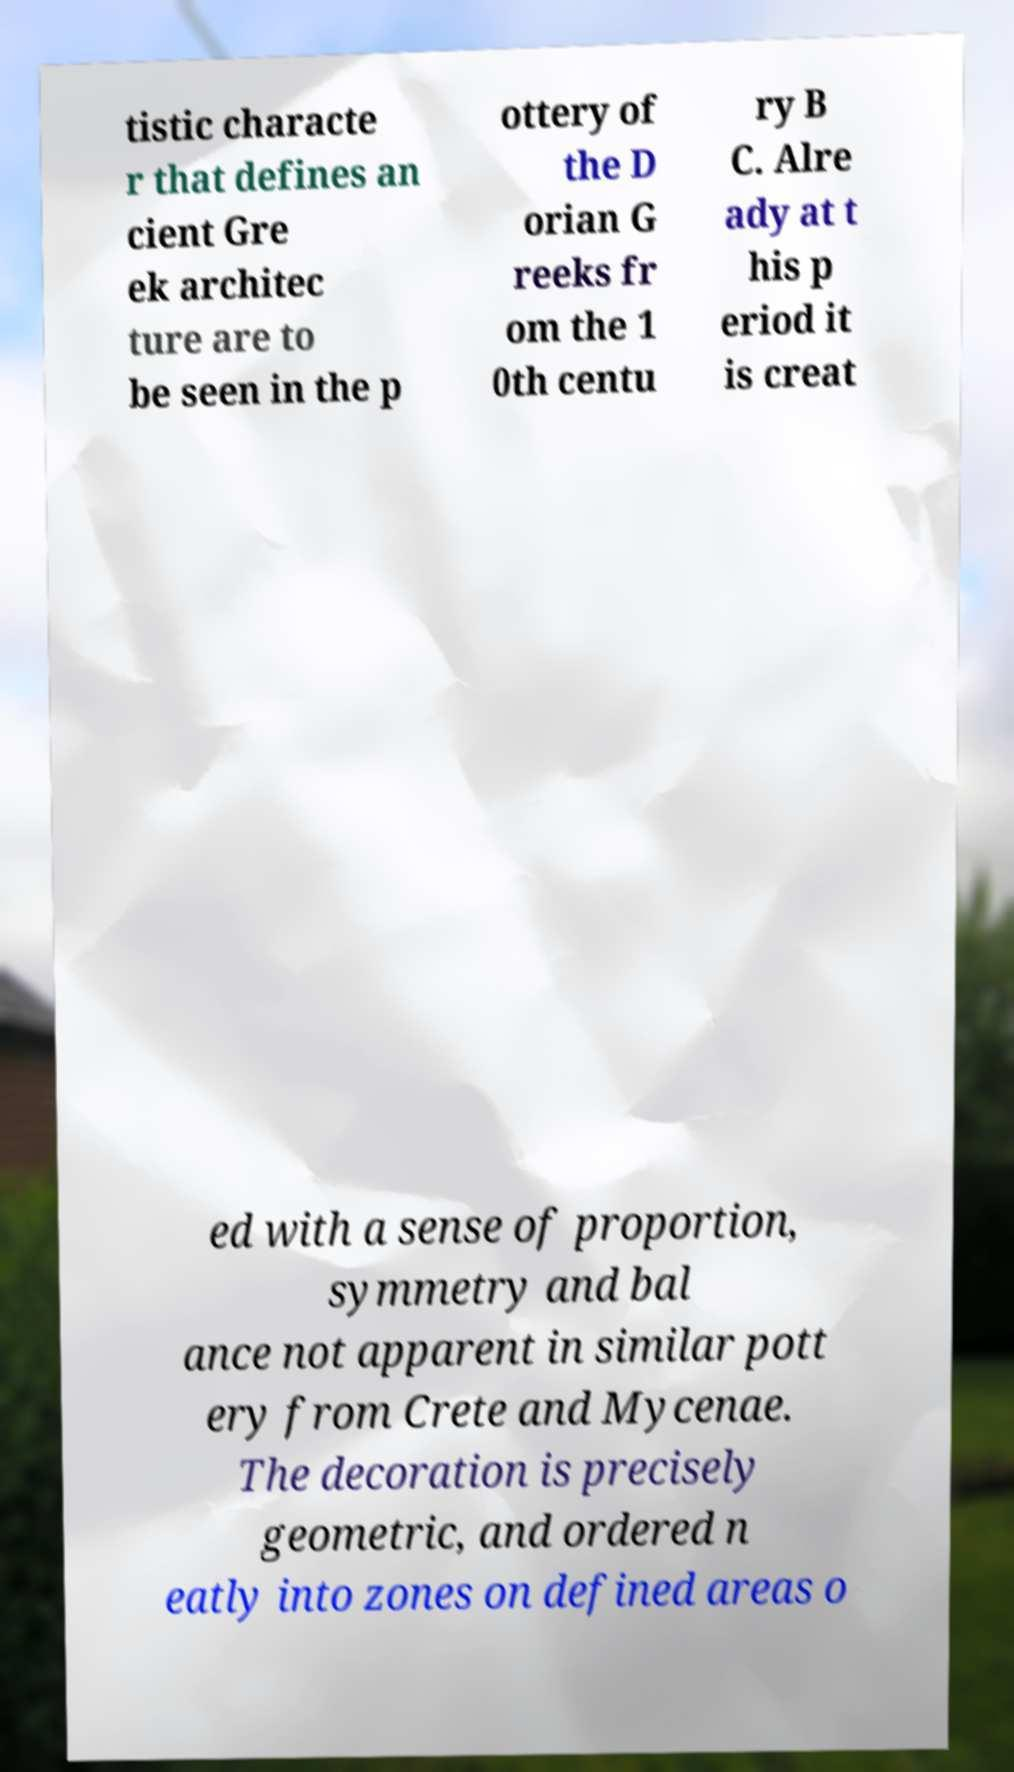I need the written content from this picture converted into text. Can you do that? tistic characte r that defines an cient Gre ek architec ture are to be seen in the p ottery of the D orian G reeks fr om the 1 0th centu ry B C. Alre ady at t his p eriod it is creat ed with a sense of proportion, symmetry and bal ance not apparent in similar pott ery from Crete and Mycenae. The decoration is precisely geometric, and ordered n eatly into zones on defined areas o 